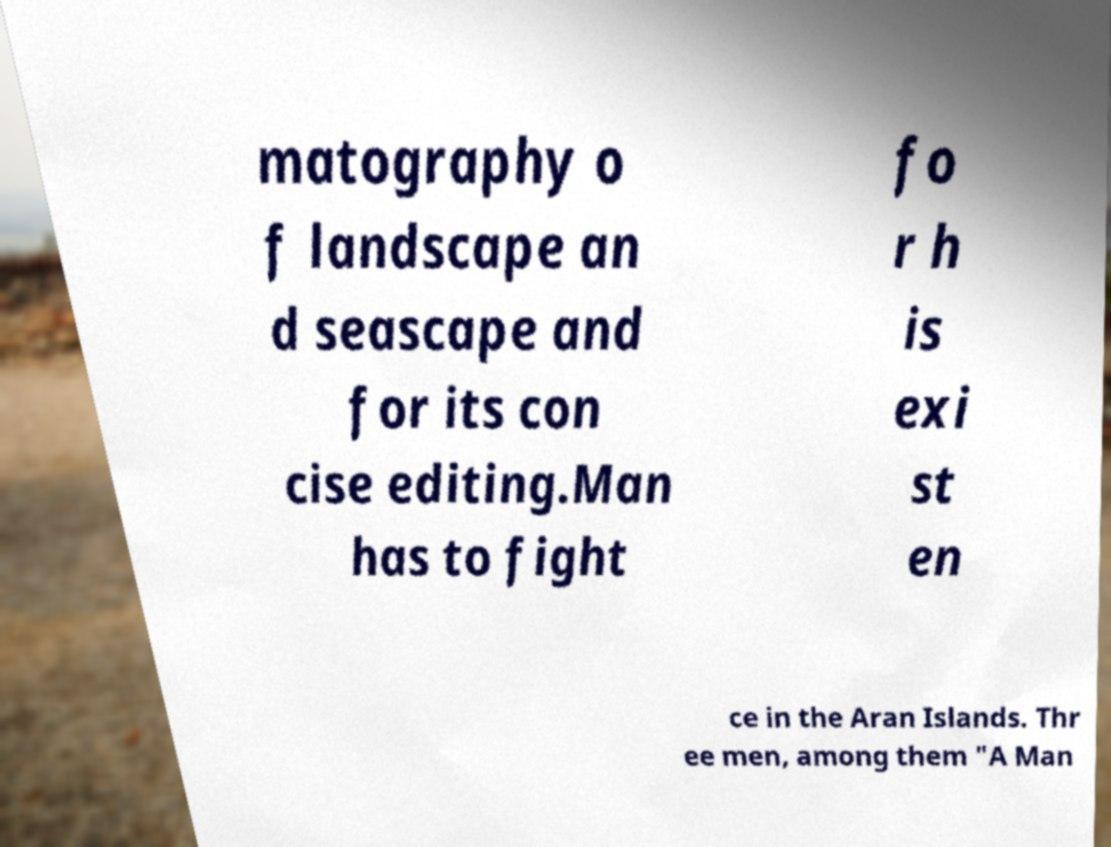I need the written content from this picture converted into text. Can you do that? matography o f landscape an d seascape and for its con cise editing.Man has to fight fo r h is exi st en ce in the Aran Islands. Thr ee men, among them "A Man 